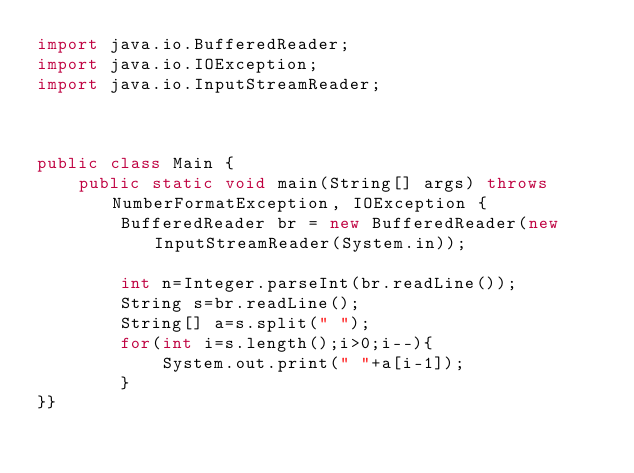<code> <loc_0><loc_0><loc_500><loc_500><_Java_>import java.io.BufferedReader;
import java.io.IOException;
import java.io.InputStreamReader;



public class Main {
	public static void main(String[] args) throws NumberFormatException, IOException {
		BufferedReader br = new BufferedReader(new InputStreamReader(System.in));
		
		int n=Integer.parseInt(br.readLine());
		String s=br.readLine();
		String[] a=s.split(" ");
		for(int i=s.length();i>0;i--){
			System.out.print(" "+a[i-1]);
		}
}}</code> 